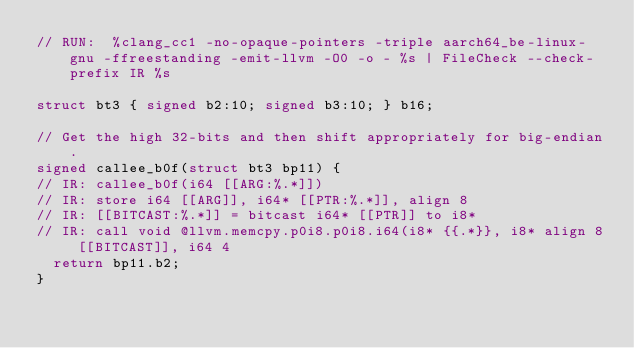<code> <loc_0><loc_0><loc_500><loc_500><_C_>// RUN:  %clang_cc1 -no-opaque-pointers -triple aarch64_be-linux-gnu -ffreestanding -emit-llvm -O0 -o - %s | FileCheck --check-prefix IR %s

struct bt3 { signed b2:10; signed b3:10; } b16;

// Get the high 32-bits and then shift appropriately for big-endian.
signed callee_b0f(struct bt3 bp11) {
// IR: callee_b0f(i64 [[ARG:%.*]])
// IR: store i64 [[ARG]], i64* [[PTR:%.*]], align 8
// IR: [[BITCAST:%.*]] = bitcast i64* [[PTR]] to i8*
// IR: call void @llvm.memcpy.p0i8.p0i8.i64(i8* {{.*}}, i8* align 8 [[BITCAST]], i64 4
  return bp11.b2;
}
</code> 